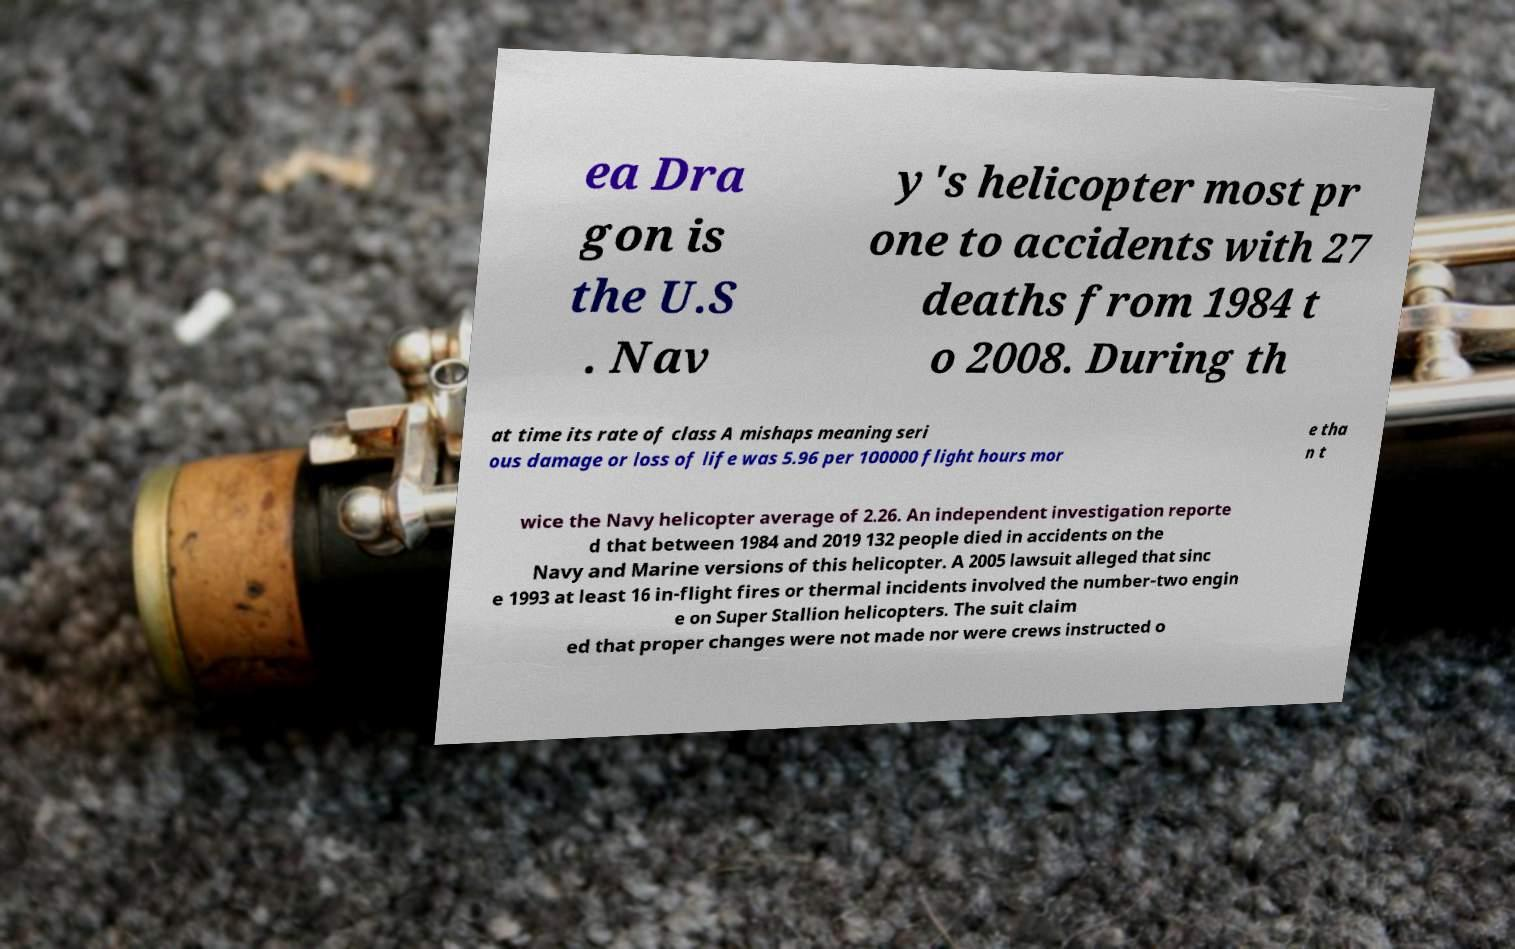I need the written content from this picture converted into text. Can you do that? ea Dra gon is the U.S . Nav y's helicopter most pr one to accidents with 27 deaths from 1984 t o 2008. During th at time its rate of class A mishaps meaning seri ous damage or loss of life was 5.96 per 100000 flight hours mor e tha n t wice the Navy helicopter average of 2.26. An independent investigation reporte d that between 1984 and 2019 132 people died in accidents on the Navy and Marine versions of this helicopter. A 2005 lawsuit alleged that sinc e 1993 at least 16 in-flight fires or thermal incidents involved the number-two engin e on Super Stallion helicopters. The suit claim ed that proper changes were not made nor were crews instructed o 